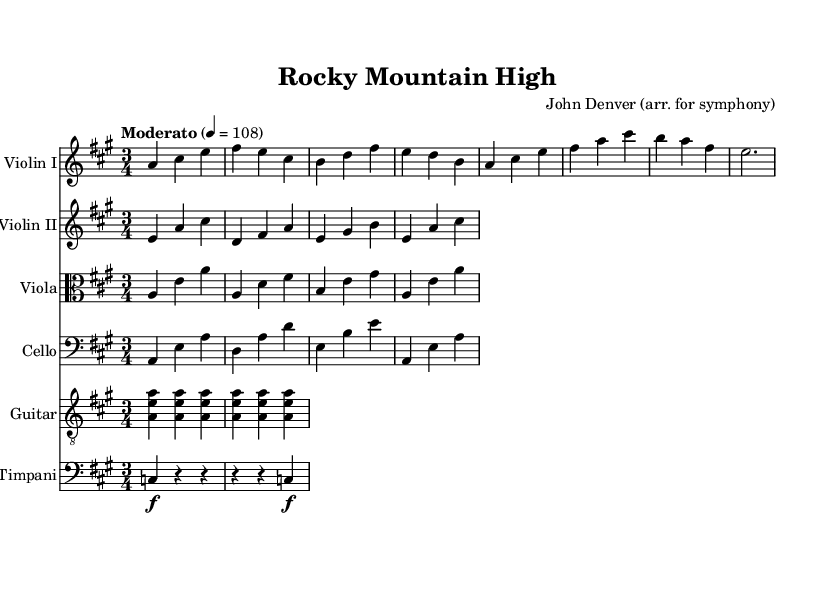What is the key signature of this music? The key signature is A major, which has three sharps: F#, C#, and G#. It can be identified by counting the sharps indicated at the beginning of the staff.
Answer: A major What is the time signature of this music? The time signature is 3/4. This can be observed on the sheet music at the beginning, which shows that there are three beats in a measure and the quarter note gets one beat.
Answer: 3/4 What is the tempo marking of this piece? The tempo marking is "Moderato" with a metronome marking of 4 = 108. This indicates a moderate speed for the piece.
Answer: Moderato, 4 = 108 How many instruments are featured in this symphonic arrangement? There are five instruments in the arrangement: Violin I, Violin II, Viola, Cello, and Acoustic Guitar. This can be counted by looking at the number of staves in the score.
Answer: Five What is the dynamic marking for the timpani in this piece? The timpani has a dynamic marking of forte (f) noted in the score, indicating that it should be played loudly. This is noted next to the relevant measures for the timpani line.
Answer: Forte Which folk tune is arranged in this symphony? The folk tune arranged in this symphony is "Rocky Mountain High" by John Denver. This is indicated in the title of the sheet music at the top.
Answer: Rocky Mountain High What is the primary key of the main melody in this arrangement? The main melody in this arrangement is primarily centered around A major, evident from the notes predominantly aligning with the A major scale.
Answer: A major 